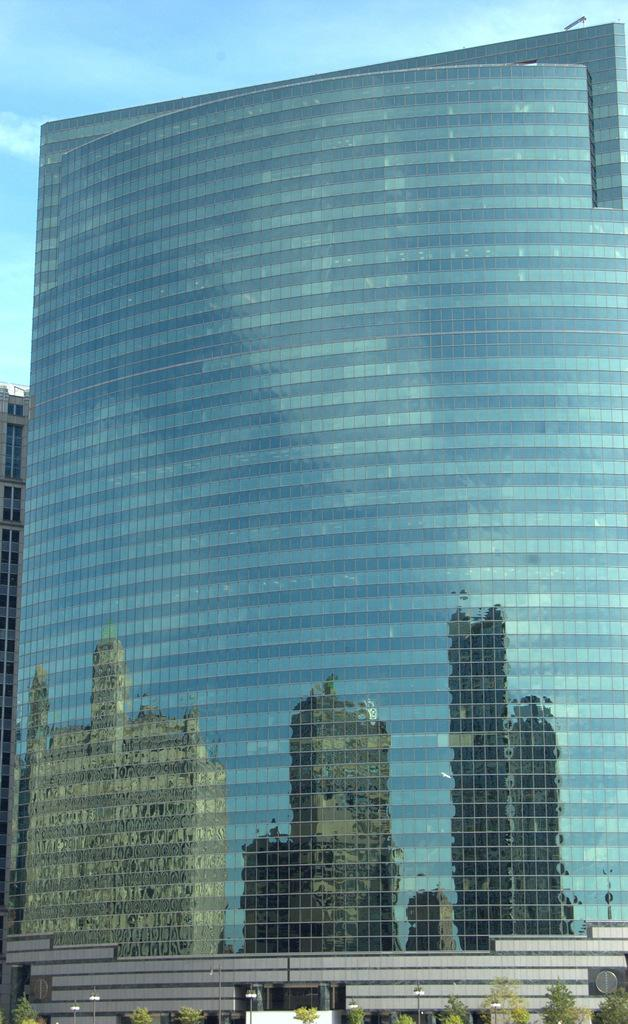What type of building is in the image? There is a skyscraper in the image. What other objects can be seen in the image? There are trees, poles, lights, and a reflection of buildings in the image. What is visible in the background of the image? The sky is visible in the background of the image. What type of body is visible in the image? There is no body present in the image; it features a skyscraper, trees, poles, lights, and a reflection of buildings. What might surprise someone about the image? The image itself is not surprising, as it depicts a skyscraper, trees, poles, lights, and a reflection of buildings. 